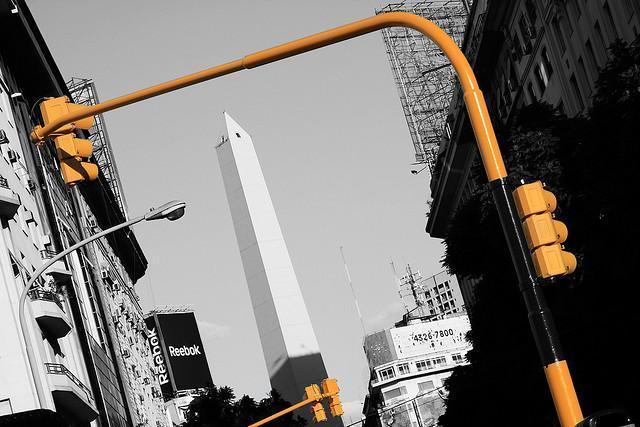How many traffic lights are there?
Give a very brief answer. 2. 